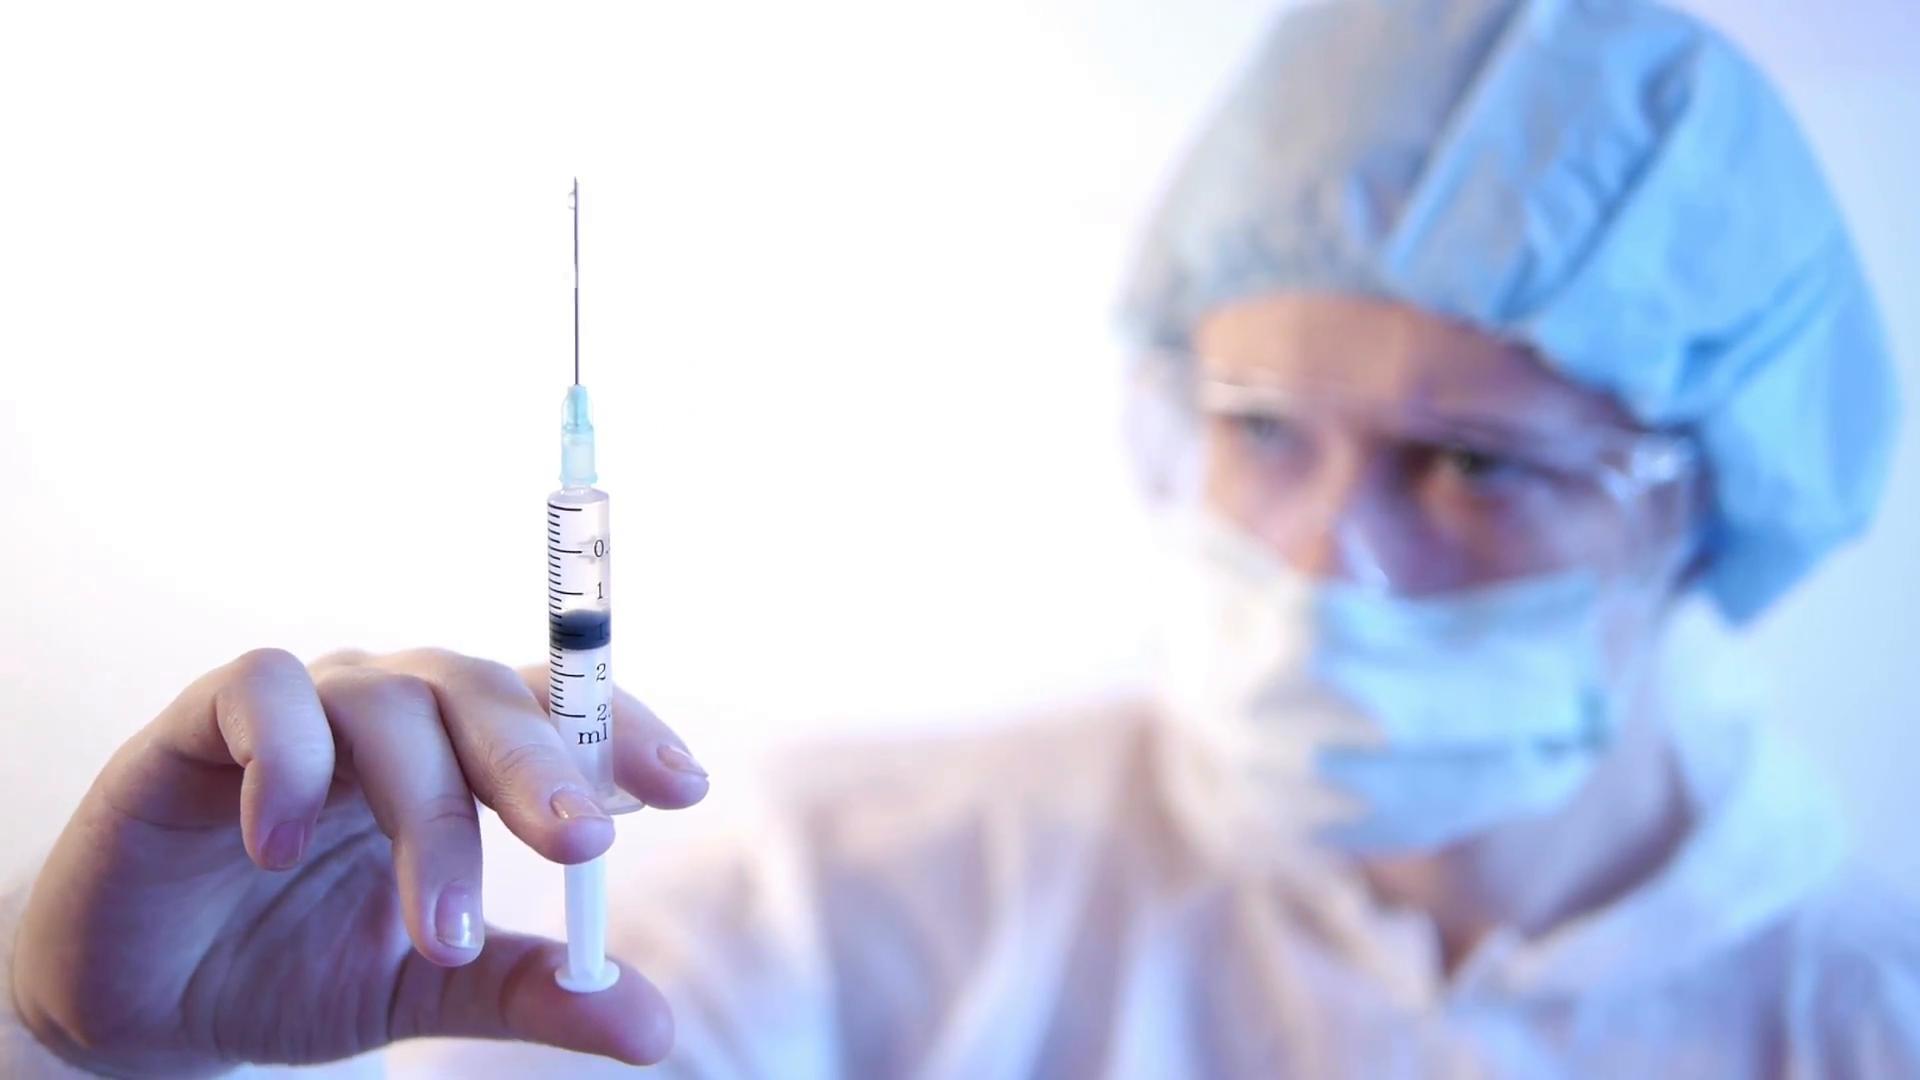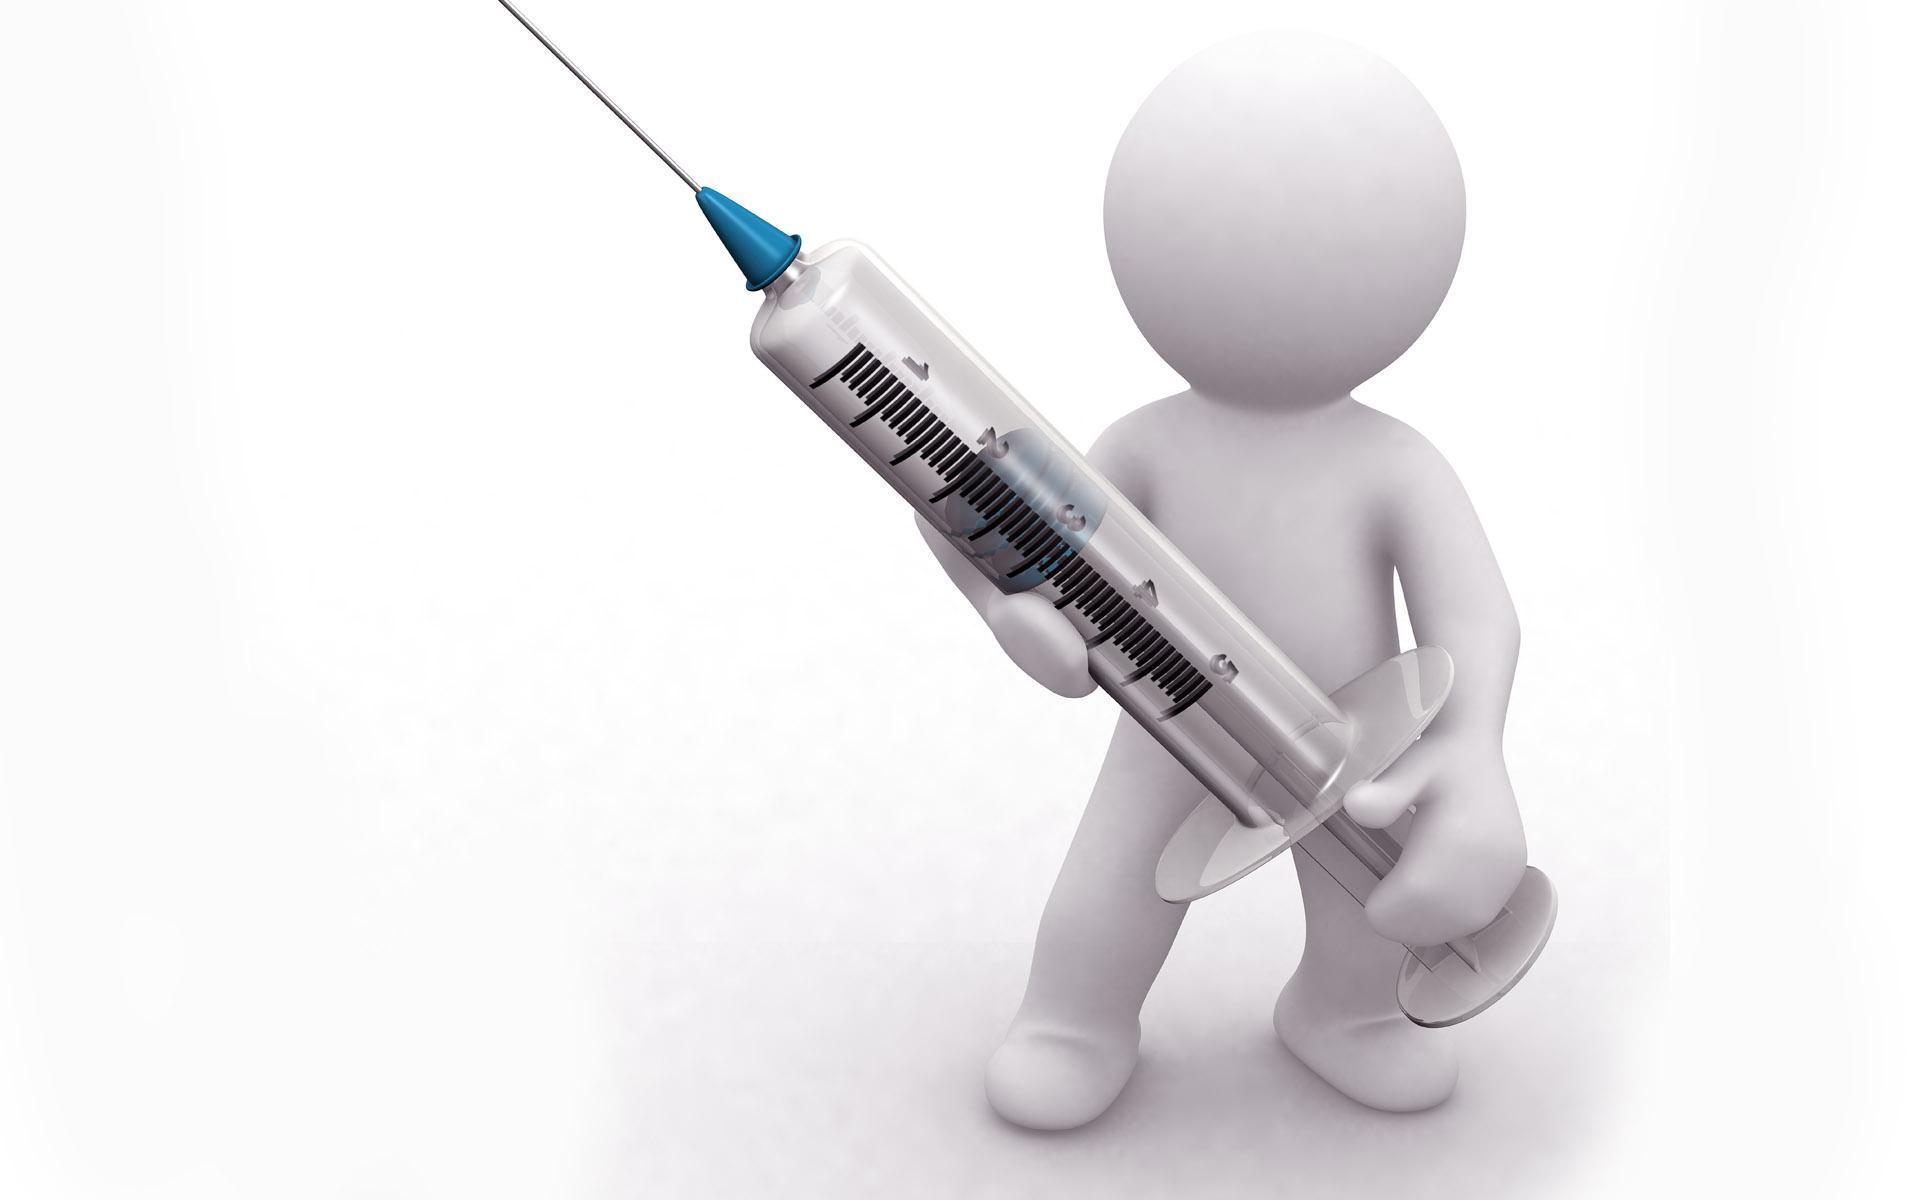The first image is the image on the left, the second image is the image on the right. Assess this claim about the two images: "In at least one image there is a single syringe being held pointing up and left.". Correct or not? Answer yes or no. Yes. The first image is the image on the left, the second image is the image on the right. Evaluate the accuracy of this statement regarding the images: "A syringe is laying on a table.". Is it true? Answer yes or no. No. 